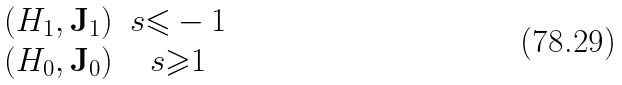Convert formula to latex. <formula><loc_0><loc_0><loc_500><loc_500>\begin{matrix} ( H _ { 1 } , \mathbf J _ { 1 } ) & s { \leqslant } - 1 \\ ( H _ { 0 } , \mathbf J _ { 0 } ) & s { \geqslant } 1 \end{matrix}</formula> 